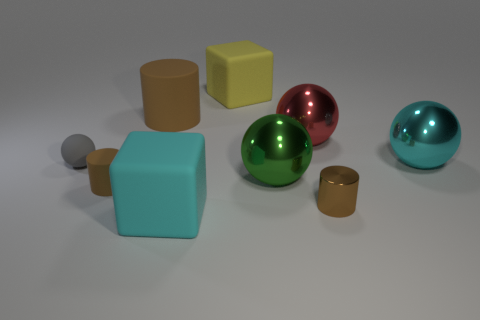How does the lighting in the image affect the appearance of the objects? The lighting in the image casts soft shadows and highlights the glossiness of the spherical objects, enhancing their three-dimensionality. The even lighting also allows for each object's color to stand out clearly without any harsh shadows or overexposed areas, showcasing the materials' properties effectively. 